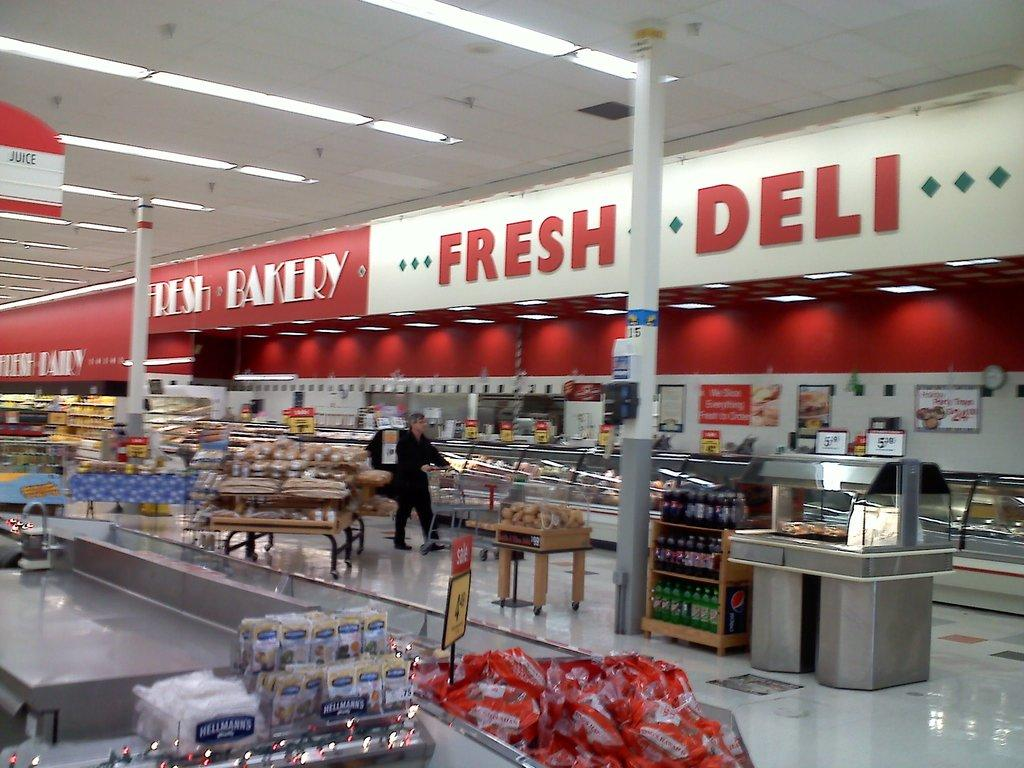<image>
Provide a brief description of the given image. A grocery store with the words fresh deli on the inside 